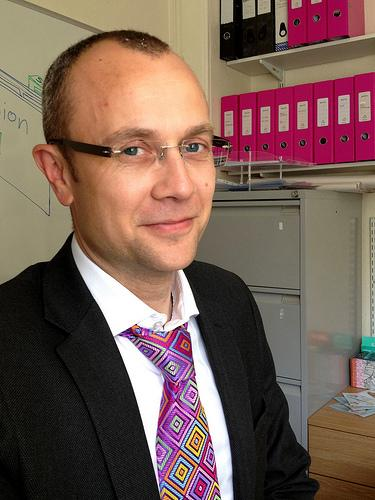Can you tell me the color of the necktie in the picture? The necktie is multicolored. Please describe the man's outfit. The man is wearing a black suit, white collared shirt, and a multicolored tie. Give an overall sentiment of the image. The sentiment of the image is positive as the man is smiling and the environment appears organized. How many pink binders are there on the shelf in the image? There are 9 pink binders on the shelf. Based on the metadata, are there any noticeable aspects regarding the quality of the image presented? There is no explicit information given about the quality of the image in the metadata. What emotion is the man in the image showing? The man is showing happiness as he is smiling. What is the primary task in this image related to object interaction analysis? The primary task is to understand the arrangement of objects, like the man's outfit and the placement of items on the shelf and table. What type of furniture is present in the image and what are its characteristics? There is a wooden table and a metallic cupboard with racks in the image. What is the color of the shirt and the coat that the man is wearing? The shirt is white and the coat is black. Provide a general description of the man's physical appearance in the image. The man has glasses, green eyes, a balding head, and is posing for a picture. 